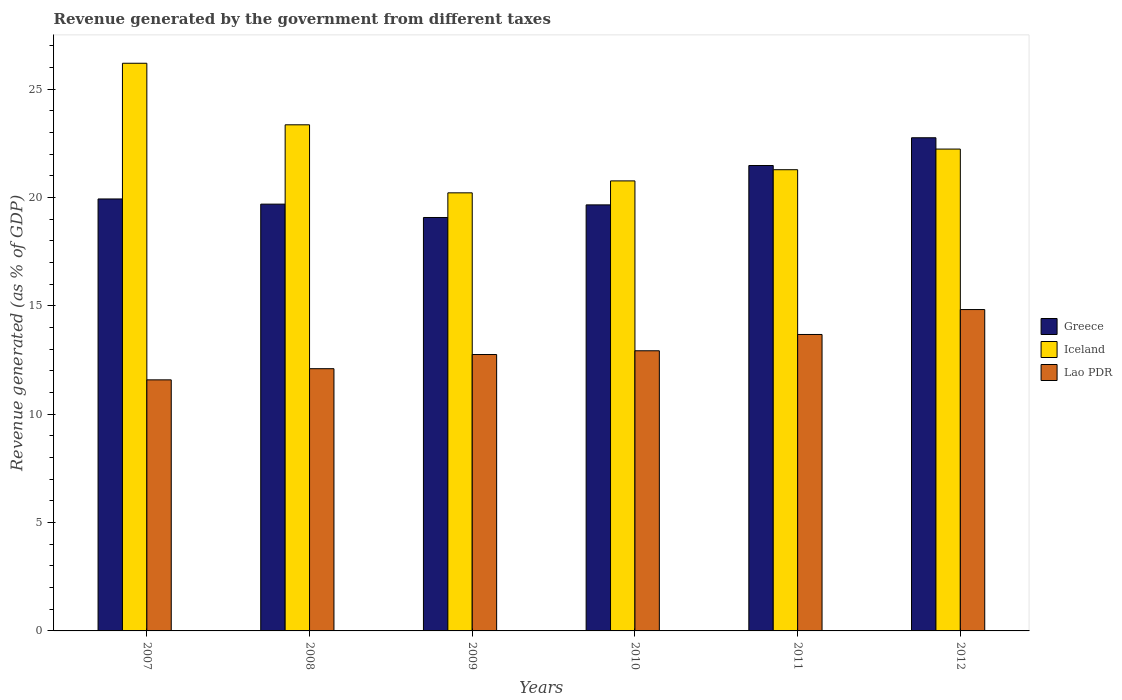How many different coloured bars are there?
Provide a short and direct response. 3. Are the number of bars on each tick of the X-axis equal?
Make the answer very short. Yes. What is the label of the 3rd group of bars from the left?
Your answer should be compact. 2009. In how many cases, is the number of bars for a given year not equal to the number of legend labels?
Your answer should be very brief. 0. What is the revenue generated by the government in Lao PDR in 2007?
Make the answer very short. 11.59. Across all years, what is the maximum revenue generated by the government in Iceland?
Your response must be concise. 26.2. Across all years, what is the minimum revenue generated by the government in Greece?
Your answer should be very brief. 19.08. In which year was the revenue generated by the government in Iceland minimum?
Keep it short and to the point. 2009. What is the total revenue generated by the government in Iceland in the graph?
Ensure brevity in your answer.  134.07. What is the difference between the revenue generated by the government in Greece in 2008 and that in 2009?
Your response must be concise. 0.62. What is the difference between the revenue generated by the government in Iceland in 2008 and the revenue generated by the government in Greece in 2007?
Offer a terse response. 3.42. What is the average revenue generated by the government in Greece per year?
Your answer should be very brief. 20.44. In the year 2009, what is the difference between the revenue generated by the government in Lao PDR and revenue generated by the government in Iceland?
Offer a very short reply. -7.46. In how many years, is the revenue generated by the government in Lao PDR greater than 22 %?
Give a very brief answer. 0. What is the ratio of the revenue generated by the government in Lao PDR in 2007 to that in 2012?
Offer a terse response. 0.78. What is the difference between the highest and the second highest revenue generated by the government in Lao PDR?
Keep it short and to the point. 1.15. What is the difference between the highest and the lowest revenue generated by the government in Lao PDR?
Your answer should be compact. 3.24. In how many years, is the revenue generated by the government in Lao PDR greater than the average revenue generated by the government in Lao PDR taken over all years?
Offer a very short reply. 2. What does the 2nd bar from the left in 2011 represents?
Your answer should be very brief. Iceland. Is it the case that in every year, the sum of the revenue generated by the government in Lao PDR and revenue generated by the government in Iceland is greater than the revenue generated by the government in Greece?
Your response must be concise. Yes. Are all the bars in the graph horizontal?
Your answer should be very brief. No. How many years are there in the graph?
Offer a very short reply. 6. What is the difference between two consecutive major ticks on the Y-axis?
Make the answer very short. 5. Does the graph contain any zero values?
Your response must be concise. No. Does the graph contain grids?
Your response must be concise. No. How many legend labels are there?
Ensure brevity in your answer.  3. How are the legend labels stacked?
Make the answer very short. Vertical. What is the title of the graph?
Your response must be concise. Revenue generated by the government from different taxes. Does "Estonia" appear as one of the legend labels in the graph?
Provide a short and direct response. No. What is the label or title of the X-axis?
Offer a very short reply. Years. What is the label or title of the Y-axis?
Make the answer very short. Revenue generated (as % of GDP). What is the Revenue generated (as % of GDP) in Greece in 2007?
Make the answer very short. 19.94. What is the Revenue generated (as % of GDP) of Iceland in 2007?
Make the answer very short. 26.2. What is the Revenue generated (as % of GDP) of Lao PDR in 2007?
Offer a terse response. 11.59. What is the Revenue generated (as % of GDP) in Greece in 2008?
Your response must be concise. 19.7. What is the Revenue generated (as % of GDP) of Iceland in 2008?
Your answer should be compact. 23.36. What is the Revenue generated (as % of GDP) in Lao PDR in 2008?
Give a very brief answer. 12.1. What is the Revenue generated (as % of GDP) of Greece in 2009?
Your answer should be very brief. 19.08. What is the Revenue generated (as % of GDP) of Iceland in 2009?
Keep it short and to the point. 20.22. What is the Revenue generated (as % of GDP) in Lao PDR in 2009?
Your answer should be compact. 12.76. What is the Revenue generated (as % of GDP) of Greece in 2010?
Offer a very short reply. 19.66. What is the Revenue generated (as % of GDP) in Iceland in 2010?
Your response must be concise. 20.77. What is the Revenue generated (as % of GDP) in Lao PDR in 2010?
Keep it short and to the point. 12.93. What is the Revenue generated (as % of GDP) of Greece in 2011?
Your response must be concise. 21.48. What is the Revenue generated (as % of GDP) in Iceland in 2011?
Your answer should be compact. 21.29. What is the Revenue generated (as % of GDP) of Lao PDR in 2011?
Offer a terse response. 13.68. What is the Revenue generated (as % of GDP) of Greece in 2012?
Your answer should be very brief. 22.76. What is the Revenue generated (as % of GDP) in Iceland in 2012?
Your answer should be compact. 22.24. What is the Revenue generated (as % of GDP) of Lao PDR in 2012?
Your answer should be very brief. 14.83. Across all years, what is the maximum Revenue generated (as % of GDP) in Greece?
Your answer should be compact. 22.76. Across all years, what is the maximum Revenue generated (as % of GDP) of Iceland?
Keep it short and to the point. 26.2. Across all years, what is the maximum Revenue generated (as % of GDP) in Lao PDR?
Your answer should be compact. 14.83. Across all years, what is the minimum Revenue generated (as % of GDP) of Greece?
Offer a terse response. 19.08. Across all years, what is the minimum Revenue generated (as % of GDP) of Iceland?
Your answer should be very brief. 20.22. Across all years, what is the minimum Revenue generated (as % of GDP) of Lao PDR?
Keep it short and to the point. 11.59. What is the total Revenue generated (as % of GDP) in Greece in the graph?
Your answer should be very brief. 122.62. What is the total Revenue generated (as % of GDP) of Iceland in the graph?
Your answer should be compact. 134.07. What is the total Revenue generated (as % of GDP) of Lao PDR in the graph?
Provide a succinct answer. 77.89. What is the difference between the Revenue generated (as % of GDP) of Greece in 2007 and that in 2008?
Offer a terse response. 0.24. What is the difference between the Revenue generated (as % of GDP) of Iceland in 2007 and that in 2008?
Give a very brief answer. 2.84. What is the difference between the Revenue generated (as % of GDP) in Lao PDR in 2007 and that in 2008?
Keep it short and to the point. -0.52. What is the difference between the Revenue generated (as % of GDP) of Greece in 2007 and that in 2009?
Offer a very short reply. 0.86. What is the difference between the Revenue generated (as % of GDP) of Iceland in 2007 and that in 2009?
Your answer should be compact. 5.98. What is the difference between the Revenue generated (as % of GDP) of Lao PDR in 2007 and that in 2009?
Offer a very short reply. -1.17. What is the difference between the Revenue generated (as % of GDP) of Greece in 2007 and that in 2010?
Provide a succinct answer. 0.27. What is the difference between the Revenue generated (as % of GDP) in Iceland in 2007 and that in 2010?
Make the answer very short. 5.43. What is the difference between the Revenue generated (as % of GDP) of Lao PDR in 2007 and that in 2010?
Provide a succinct answer. -1.34. What is the difference between the Revenue generated (as % of GDP) in Greece in 2007 and that in 2011?
Provide a short and direct response. -1.54. What is the difference between the Revenue generated (as % of GDP) of Iceland in 2007 and that in 2011?
Ensure brevity in your answer.  4.91. What is the difference between the Revenue generated (as % of GDP) of Lao PDR in 2007 and that in 2011?
Make the answer very short. -2.09. What is the difference between the Revenue generated (as % of GDP) of Greece in 2007 and that in 2012?
Offer a very short reply. -2.82. What is the difference between the Revenue generated (as % of GDP) of Iceland in 2007 and that in 2012?
Ensure brevity in your answer.  3.96. What is the difference between the Revenue generated (as % of GDP) in Lao PDR in 2007 and that in 2012?
Your answer should be compact. -3.24. What is the difference between the Revenue generated (as % of GDP) of Greece in 2008 and that in 2009?
Provide a succinct answer. 0.62. What is the difference between the Revenue generated (as % of GDP) in Iceland in 2008 and that in 2009?
Offer a terse response. 3.14. What is the difference between the Revenue generated (as % of GDP) in Lao PDR in 2008 and that in 2009?
Provide a short and direct response. -0.65. What is the difference between the Revenue generated (as % of GDP) of Greece in 2008 and that in 2010?
Provide a succinct answer. 0.03. What is the difference between the Revenue generated (as % of GDP) of Iceland in 2008 and that in 2010?
Make the answer very short. 2.59. What is the difference between the Revenue generated (as % of GDP) in Lao PDR in 2008 and that in 2010?
Keep it short and to the point. -0.83. What is the difference between the Revenue generated (as % of GDP) of Greece in 2008 and that in 2011?
Your answer should be very brief. -1.78. What is the difference between the Revenue generated (as % of GDP) in Iceland in 2008 and that in 2011?
Provide a short and direct response. 2.07. What is the difference between the Revenue generated (as % of GDP) of Lao PDR in 2008 and that in 2011?
Your answer should be compact. -1.58. What is the difference between the Revenue generated (as % of GDP) of Greece in 2008 and that in 2012?
Ensure brevity in your answer.  -3.06. What is the difference between the Revenue generated (as % of GDP) in Iceland in 2008 and that in 2012?
Ensure brevity in your answer.  1.12. What is the difference between the Revenue generated (as % of GDP) of Lao PDR in 2008 and that in 2012?
Give a very brief answer. -2.73. What is the difference between the Revenue generated (as % of GDP) of Greece in 2009 and that in 2010?
Make the answer very short. -0.58. What is the difference between the Revenue generated (as % of GDP) in Iceland in 2009 and that in 2010?
Keep it short and to the point. -0.55. What is the difference between the Revenue generated (as % of GDP) of Lao PDR in 2009 and that in 2010?
Keep it short and to the point. -0.17. What is the difference between the Revenue generated (as % of GDP) of Greece in 2009 and that in 2011?
Offer a terse response. -2.4. What is the difference between the Revenue generated (as % of GDP) in Iceland in 2009 and that in 2011?
Your answer should be very brief. -1.07. What is the difference between the Revenue generated (as % of GDP) of Lao PDR in 2009 and that in 2011?
Your answer should be compact. -0.93. What is the difference between the Revenue generated (as % of GDP) of Greece in 2009 and that in 2012?
Provide a succinct answer. -3.68. What is the difference between the Revenue generated (as % of GDP) in Iceland in 2009 and that in 2012?
Offer a very short reply. -2.02. What is the difference between the Revenue generated (as % of GDP) of Lao PDR in 2009 and that in 2012?
Keep it short and to the point. -2.07. What is the difference between the Revenue generated (as % of GDP) of Greece in 2010 and that in 2011?
Provide a succinct answer. -1.82. What is the difference between the Revenue generated (as % of GDP) in Iceland in 2010 and that in 2011?
Keep it short and to the point. -0.52. What is the difference between the Revenue generated (as % of GDP) in Lao PDR in 2010 and that in 2011?
Your answer should be very brief. -0.75. What is the difference between the Revenue generated (as % of GDP) of Greece in 2010 and that in 2012?
Provide a short and direct response. -3.1. What is the difference between the Revenue generated (as % of GDP) in Iceland in 2010 and that in 2012?
Keep it short and to the point. -1.47. What is the difference between the Revenue generated (as % of GDP) of Lao PDR in 2010 and that in 2012?
Keep it short and to the point. -1.9. What is the difference between the Revenue generated (as % of GDP) in Greece in 2011 and that in 2012?
Make the answer very short. -1.28. What is the difference between the Revenue generated (as % of GDP) in Iceland in 2011 and that in 2012?
Your response must be concise. -0.95. What is the difference between the Revenue generated (as % of GDP) of Lao PDR in 2011 and that in 2012?
Keep it short and to the point. -1.15. What is the difference between the Revenue generated (as % of GDP) in Greece in 2007 and the Revenue generated (as % of GDP) in Iceland in 2008?
Your response must be concise. -3.42. What is the difference between the Revenue generated (as % of GDP) in Greece in 2007 and the Revenue generated (as % of GDP) in Lao PDR in 2008?
Offer a very short reply. 7.83. What is the difference between the Revenue generated (as % of GDP) in Iceland in 2007 and the Revenue generated (as % of GDP) in Lao PDR in 2008?
Provide a succinct answer. 14.1. What is the difference between the Revenue generated (as % of GDP) of Greece in 2007 and the Revenue generated (as % of GDP) of Iceland in 2009?
Provide a short and direct response. -0.28. What is the difference between the Revenue generated (as % of GDP) in Greece in 2007 and the Revenue generated (as % of GDP) in Lao PDR in 2009?
Offer a terse response. 7.18. What is the difference between the Revenue generated (as % of GDP) in Iceland in 2007 and the Revenue generated (as % of GDP) in Lao PDR in 2009?
Your response must be concise. 13.44. What is the difference between the Revenue generated (as % of GDP) of Greece in 2007 and the Revenue generated (as % of GDP) of Iceland in 2010?
Provide a short and direct response. -0.83. What is the difference between the Revenue generated (as % of GDP) of Greece in 2007 and the Revenue generated (as % of GDP) of Lao PDR in 2010?
Offer a terse response. 7.01. What is the difference between the Revenue generated (as % of GDP) of Iceland in 2007 and the Revenue generated (as % of GDP) of Lao PDR in 2010?
Make the answer very short. 13.27. What is the difference between the Revenue generated (as % of GDP) in Greece in 2007 and the Revenue generated (as % of GDP) in Iceland in 2011?
Your answer should be very brief. -1.35. What is the difference between the Revenue generated (as % of GDP) of Greece in 2007 and the Revenue generated (as % of GDP) of Lao PDR in 2011?
Ensure brevity in your answer.  6.25. What is the difference between the Revenue generated (as % of GDP) of Iceland in 2007 and the Revenue generated (as % of GDP) of Lao PDR in 2011?
Your response must be concise. 12.52. What is the difference between the Revenue generated (as % of GDP) in Greece in 2007 and the Revenue generated (as % of GDP) in Iceland in 2012?
Give a very brief answer. -2.3. What is the difference between the Revenue generated (as % of GDP) of Greece in 2007 and the Revenue generated (as % of GDP) of Lao PDR in 2012?
Your answer should be compact. 5.1. What is the difference between the Revenue generated (as % of GDP) of Iceland in 2007 and the Revenue generated (as % of GDP) of Lao PDR in 2012?
Keep it short and to the point. 11.37. What is the difference between the Revenue generated (as % of GDP) in Greece in 2008 and the Revenue generated (as % of GDP) in Iceland in 2009?
Provide a succinct answer. -0.52. What is the difference between the Revenue generated (as % of GDP) in Greece in 2008 and the Revenue generated (as % of GDP) in Lao PDR in 2009?
Provide a short and direct response. 6.94. What is the difference between the Revenue generated (as % of GDP) of Iceland in 2008 and the Revenue generated (as % of GDP) of Lao PDR in 2009?
Ensure brevity in your answer.  10.6. What is the difference between the Revenue generated (as % of GDP) in Greece in 2008 and the Revenue generated (as % of GDP) in Iceland in 2010?
Make the answer very short. -1.07. What is the difference between the Revenue generated (as % of GDP) of Greece in 2008 and the Revenue generated (as % of GDP) of Lao PDR in 2010?
Offer a terse response. 6.77. What is the difference between the Revenue generated (as % of GDP) of Iceland in 2008 and the Revenue generated (as % of GDP) of Lao PDR in 2010?
Make the answer very short. 10.43. What is the difference between the Revenue generated (as % of GDP) of Greece in 2008 and the Revenue generated (as % of GDP) of Iceland in 2011?
Give a very brief answer. -1.59. What is the difference between the Revenue generated (as % of GDP) of Greece in 2008 and the Revenue generated (as % of GDP) of Lao PDR in 2011?
Give a very brief answer. 6.02. What is the difference between the Revenue generated (as % of GDP) in Iceland in 2008 and the Revenue generated (as % of GDP) in Lao PDR in 2011?
Your response must be concise. 9.68. What is the difference between the Revenue generated (as % of GDP) in Greece in 2008 and the Revenue generated (as % of GDP) in Iceland in 2012?
Make the answer very short. -2.54. What is the difference between the Revenue generated (as % of GDP) of Greece in 2008 and the Revenue generated (as % of GDP) of Lao PDR in 2012?
Provide a succinct answer. 4.87. What is the difference between the Revenue generated (as % of GDP) of Iceland in 2008 and the Revenue generated (as % of GDP) of Lao PDR in 2012?
Keep it short and to the point. 8.53. What is the difference between the Revenue generated (as % of GDP) of Greece in 2009 and the Revenue generated (as % of GDP) of Iceland in 2010?
Offer a terse response. -1.69. What is the difference between the Revenue generated (as % of GDP) in Greece in 2009 and the Revenue generated (as % of GDP) in Lao PDR in 2010?
Your answer should be compact. 6.15. What is the difference between the Revenue generated (as % of GDP) in Iceland in 2009 and the Revenue generated (as % of GDP) in Lao PDR in 2010?
Offer a terse response. 7.29. What is the difference between the Revenue generated (as % of GDP) of Greece in 2009 and the Revenue generated (as % of GDP) of Iceland in 2011?
Your answer should be very brief. -2.21. What is the difference between the Revenue generated (as % of GDP) of Greece in 2009 and the Revenue generated (as % of GDP) of Lao PDR in 2011?
Give a very brief answer. 5.4. What is the difference between the Revenue generated (as % of GDP) of Iceland in 2009 and the Revenue generated (as % of GDP) of Lao PDR in 2011?
Give a very brief answer. 6.54. What is the difference between the Revenue generated (as % of GDP) of Greece in 2009 and the Revenue generated (as % of GDP) of Iceland in 2012?
Your answer should be compact. -3.16. What is the difference between the Revenue generated (as % of GDP) of Greece in 2009 and the Revenue generated (as % of GDP) of Lao PDR in 2012?
Your response must be concise. 4.25. What is the difference between the Revenue generated (as % of GDP) of Iceland in 2009 and the Revenue generated (as % of GDP) of Lao PDR in 2012?
Provide a succinct answer. 5.39. What is the difference between the Revenue generated (as % of GDP) in Greece in 2010 and the Revenue generated (as % of GDP) in Iceland in 2011?
Offer a very short reply. -1.62. What is the difference between the Revenue generated (as % of GDP) of Greece in 2010 and the Revenue generated (as % of GDP) of Lao PDR in 2011?
Provide a short and direct response. 5.98. What is the difference between the Revenue generated (as % of GDP) in Iceland in 2010 and the Revenue generated (as % of GDP) in Lao PDR in 2011?
Your answer should be compact. 7.09. What is the difference between the Revenue generated (as % of GDP) of Greece in 2010 and the Revenue generated (as % of GDP) of Iceland in 2012?
Your answer should be very brief. -2.58. What is the difference between the Revenue generated (as % of GDP) in Greece in 2010 and the Revenue generated (as % of GDP) in Lao PDR in 2012?
Provide a succinct answer. 4.83. What is the difference between the Revenue generated (as % of GDP) of Iceland in 2010 and the Revenue generated (as % of GDP) of Lao PDR in 2012?
Your response must be concise. 5.94. What is the difference between the Revenue generated (as % of GDP) in Greece in 2011 and the Revenue generated (as % of GDP) in Iceland in 2012?
Offer a very short reply. -0.76. What is the difference between the Revenue generated (as % of GDP) in Greece in 2011 and the Revenue generated (as % of GDP) in Lao PDR in 2012?
Make the answer very short. 6.65. What is the difference between the Revenue generated (as % of GDP) in Iceland in 2011 and the Revenue generated (as % of GDP) in Lao PDR in 2012?
Your response must be concise. 6.45. What is the average Revenue generated (as % of GDP) in Greece per year?
Ensure brevity in your answer.  20.44. What is the average Revenue generated (as % of GDP) in Iceland per year?
Your response must be concise. 22.35. What is the average Revenue generated (as % of GDP) in Lao PDR per year?
Provide a short and direct response. 12.98. In the year 2007, what is the difference between the Revenue generated (as % of GDP) of Greece and Revenue generated (as % of GDP) of Iceland?
Keep it short and to the point. -6.26. In the year 2007, what is the difference between the Revenue generated (as % of GDP) of Greece and Revenue generated (as % of GDP) of Lao PDR?
Provide a short and direct response. 8.35. In the year 2007, what is the difference between the Revenue generated (as % of GDP) of Iceland and Revenue generated (as % of GDP) of Lao PDR?
Offer a very short reply. 14.61. In the year 2008, what is the difference between the Revenue generated (as % of GDP) in Greece and Revenue generated (as % of GDP) in Iceland?
Provide a short and direct response. -3.66. In the year 2008, what is the difference between the Revenue generated (as % of GDP) of Greece and Revenue generated (as % of GDP) of Lao PDR?
Make the answer very short. 7.59. In the year 2008, what is the difference between the Revenue generated (as % of GDP) of Iceland and Revenue generated (as % of GDP) of Lao PDR?
Give a very brief answer. 11.26. In the year 2009, what is the difference between the Revenue generated (as % of GDP) in Greece and Revenue generated (as % of GDP) in Iceland?
Provide a succinct answer. -1.14. In the year 2009, what is the difference between the Revenue generated (as % of GDP) in Greece and Revenue generated (as % of GDP) in Lao PDR?
Offer a terse response. 6.32. In the year 2009, what is the difference between the Revenue generated (as % of GDP) of Iceland and Revenue generated (as % of GDP) of Lao PDR?
Your response must be concise. 7.46. In the year 2010, what is the difference between the Revenue generated (as % of GDP) in Greece and Revenue generated (as % of GDP) in Iceland?
Offer a terse response. -1.11. In the year 2010, what is the difference between the Revenue generated (as % of GDP) in Greece and Revenue generated (as % of GDP) in Lao PDR?
Provide a short and direct response. 6.73. In the year 2010, what is the difference between the Revenue generated (as % of GDP) in Iceland and Revenue generated (as % of GDP) in Lao PDR?
Offer a very short reply. 7.84. In the year 2011, what is the difference between the Revenue generated (as % of GDP) in Greece and Revenue generated (as % of GDP) in Iceland?
Ensure brevity in your answer.  0.19. In the year 2011, what is the difference between the Revenue generated (as % of GDP) in Greece and Revenue generated (as % of GDP) in Lao PDR?
Give a very brief answer. 7.8. In the year 2011, what is the difference between the Revenue generated (as % of GDP) of Iceland and Revenue generated (as % of GDP) of Lao PDR?
Your response must be concise. 7.6. In the year 2012, what is the difference between the Revenue generated (as % of GDP) in Greece and Revenue generated (as % of GDP) in Iceland?
Give a very brief answer. 0.52. In the year 2012, what is the difference between the Revenue generated (as % of GDP) of Greece and Revenue generated (as % of GDP) of Lao PDR?
Offer a very short reply. 7.93. In the year 2012, what is the difference between the Revenue generated (as % of GDP) of Iceland and Revenue generated (as % of GDP) of Lao PDR?
Your answer should be very brief. 7.41. What is the ratio of the Revenue generated (as % of GDP) of Greece in 2007 to that in 2008?
Offer a very short reply. 1.01. What is the ratio of the Revenue generated (as % of GDP) in Iceland in 2007 to that in 2008?
Keep it short and to the point. 1.12. What is the ratio of the Revenue generated (as % of GDP) of Lao PDR in 2007 to that in 2008?
Your response must be concise. 0.96. What is the ratio of the Revenue generated (as % of GDP) in Greece in 2007 to that in 2009?
Provide a short and direct response. 1.04. What is the ratio of the Revenue generated (as % of GDP) of Iceland in 2007 to that in 2009?
Offer a terse response. 1.3. What is the ratio of the Revenue generated (as % of GDP) of Lao PDR in 2007 to that in 2009?
Offer a terse response. 0.91. What is the ratio of the Revenue generated (as % of GDP) of Greece in 2007 to that in 2010?
Your answer should be very brief. 1.01. What is the ratio of the Revenue generated (as % of GDP) in Iceland in 2007 to that in 2010?
Keep it short and to the point. 1.26. What is the ratio of the Revenue generated (as % of GDP) in Lao PDR in 2007 to that in 2010?
Keep it short and to the point. 0.9. What is the ratio of the Revenue generated (as % of GDP) in Greece in 2007 to that in 2011?
Offer a terse response. 0.93. What is the ratio of the Revenue generated (as % of GDP) in Iceland in 2007 to that in 2011?
Ensure brevity in your answer.  1.23. What is the ratio of the Revenue generated (as % of GDP) of Lao PDR in 2007 to that in 2011?
Provide a succinct answer. 0.85. What is the ratio of the Revenue generated (as % of GDP) of Greece in 2007 to that in 2012?
Make the answer very short. 0.88. What is the ratio of the Revenue generated (as % of GDP) in Iceland in 2007 to that in 2012?
Provide a short and direct response. 1.18. What is the ratio of the Revenue generated (as % of GDP) of Lao PDR in 2007 to that in 2012?
Your answer should be very brief. 0.78. What is the ratio of the Revenue generated (as % of GDP) in Greece in 2008 to that in 2009?
Give a very brief answer. 1.03. What is the ratio of the Revenue generated (as % of GDP) of Iceland in 2008 to that in 2009?
Make the answer very short. 1.16. What is the ratio of the Revenue generated (as % of GDP) in Lao PDR in 2008 to that in 2009?
Provide a succinct answer. 0.95. What is the ratio of the Revenue generated (as % of GDP) of Greece in 2008 to that in 2010?
Provide a succinct answer. 1. What is the ratio of the Revenue generated (as % of GDP) of Iceland in 2008 to that in 2010?
Offer a terse response. 1.12. What is the ratio of the Revenue generated (as % of GDP) of Lao PDR in 2008 to that in 2010?
Ensure brevity in your answer.  0.94. What is the ratio of the Revenue generated (as % of GDP) of Greece in 2008 to that in 2011?
Your answer should be compact. 0.92. What is the ratio of the Revenue generated (as % of GDP) in Iceland in 2008 to that in 2011?
Make the answer very short. 1.1. What is the ratio of the Revenue generated (as % of GDP) of Lao PDR in 2008 to that in 2011?
Give a very brief answer. 0.88. What is the ratio of the Revenue generated (as % of GDP) in Greece in 2008 to that in 2012?
Your answer should be compact. 0.87. What is the ratio of the Revenue generated (as % of GDP) in Iceland in 2008 to that in 2012?
Provide a succinct answer. 1.05. What is the ratio of the Revenue generated (as % of GDP) of Lao PDR in 2008 to that in 2012?
Your answer should be very brief. 0.82. What is the ratio of the Revenue generated (as % of GDP) of Greece in 2009 to that in 2010?
Provide a short and direct response. 0.97. What is the ratio of the Revenue generated (as % of GDP) of Iceland in 2009 to that in 2010?
Give a very brief answer. 0.97. What is the ratio of the Revenue generated (as % of GDP) in Lao PDR in 2009 to that in 2010?
Offer a very short reply. 0.99. What is the ratio of the Revenue generated (as % of GDP) in Greece in 2009 to that in 2011?
Make the answer very short. 0.89. What is the ratio of the Revenue generated (as % of GDP) in Iceland in 2009 to that in 2011?
Give a very brief answer. 0.95. What is the ratio of the Revenue generated (as % of GDP) of Lao PDR in 2009 to that in 2011?
Your answer should be compact. 0.93. What is the ratio of the Revenue generated (as % of GDP) in Greece in 2009 to that in 2012?
Keep it short and to the point. 0.84. What is the ratio of the Revenue generated (as % of GDP) of Iceland in 2009 to that in 2012?
Your response must be concise. 0.91. What is the ratio of the Revenue generated (as % of GDP) in Lao PDR in 2009 to that in 2012?
Make the answer very short. 0.86. What is the ratio of the Revenue generated (as % of GDP) of Greece in 2010 to that in 2011?
Your answer should be very brief. 0.92. What is the ratio of the Revenue generated (as % of GDP) in Iceland in 2010 to that in 2011?
Your answer should be compact. 0.98. What is the ratio of the Revenue generated (as % of GDP) in Lao PDR in 2010 to that in 2011?
Keep it short and to the point. 0.94. What is the ratio of the Revenue generated (as % of GDP) of Greece in 2010 to that in 2012?
Your answer should be compact. 0.86. What is the ratio of the Revenue generated (as % of GDP) of Iceland in 2010 to that in 2012?
Provide a succinct answer. 0.93. What is the ratio of the Revenue generated (as % of GDP) of Lao PDR in 2010 to that in 2012?
Offer a very short reply. 0.87. What is the ratio of the Revenue generated (as % of GDP) of Greece in 2011 to that in 2012?
Offer a very short reply. 0.94. What is the ratio of the Revenue generated (as % of GDP) in Iceland in 2011 to that in 2012?
Your answer should be very brief. 0.96. What is the ratio of the Revenue generated (as % of GDP) in Lao PDR in 2011 to that in 2012?
Provide a short and direct response. 0.92. What is the difference between the highest and the second highest Revenue generated (as % of GDP) of Greece?
Your response must be concise. 1.28. What is the difference between the highest and the second highest Revenue generated (as % of GDP) of Iceland?
Give a very brief answer. 2.84. What is the difference between the highest and the second highest Revenue generated (as % of GDP) in Lao PDR?
Offer a very short reply. 1.15. What is the difference between the highest and the lowest Revenue generated (as % of GDP) in Greece?
Provide a succinct answer. 3.68. What is the difference between the highest and the lowest Revenue generated (as % of GDP) in Iceland?
Provide a short and direct response. 5.98. What is the difference between the highest and the lowest Revenue generated (as % of GDP) of Lao PDR?
Give a very brief answer. 3.24. 